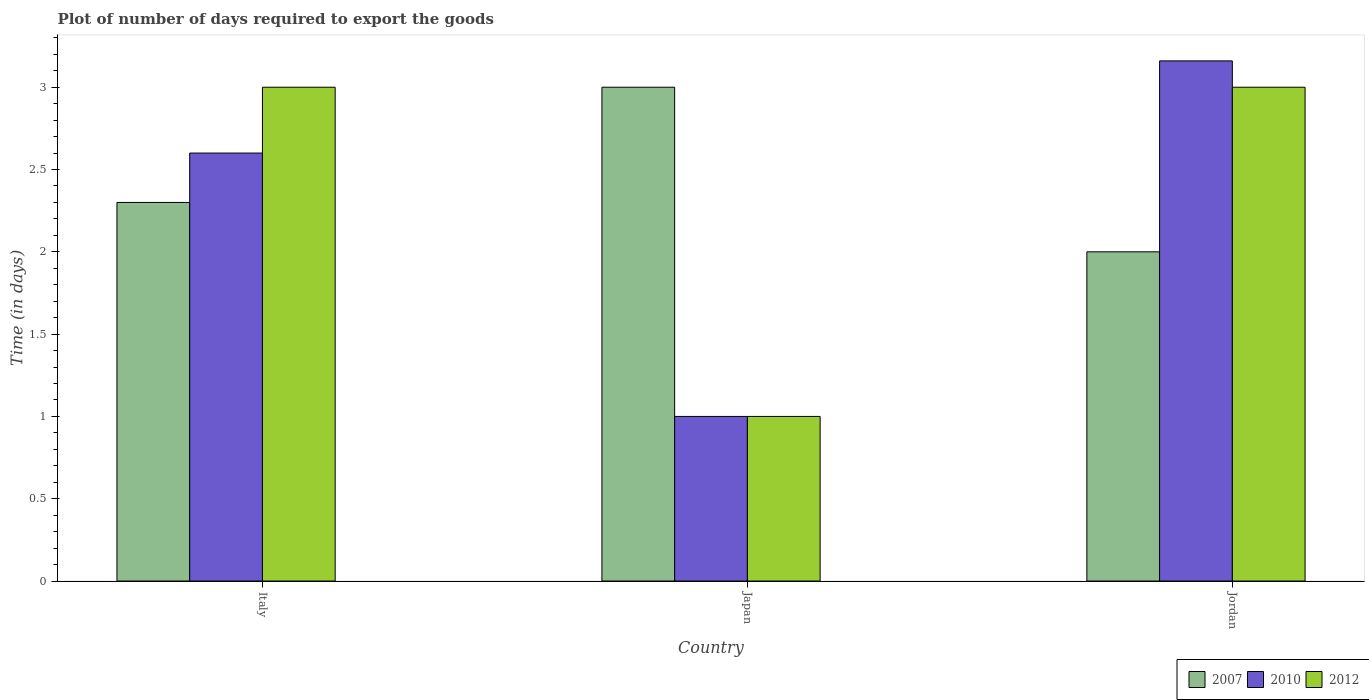How many different coloured bars are there?
Provide a short and direct response. 3. How many groups of bars are there?
Make the answer very short. 3. Are the number of bars per tick equal to the number of legend labels?
Make the answer very short. Yes. How many bars are there on the 3rd tick from the left?
Give a very brief answer. 3. What is the label of the 3rd group of bars from the left?
Keep it short and to the point. Jordan. In how many cases, is the number of bars for a given country not equal to the number of legend labels?
Your answer should be very brief. 0. What is the time required to export goods in 2012 in Italy?
Offer a terse response. 3. Across all countries, what is the maximum time required to export goods in 2010?
Provide a short and direct response. 3.16. In which country was the time required to export goods in 2012 maximum?
Provide a succinct answer. Italy. In which country was the time required to export goods in 2007 minimum?
Your answer should be very brief. Jordan. What is the total time required to export goods in 2010 in the graph?
Your answer should be very brief. 6.76. What is the difference between the time required to export goods in 2007 in Italy and that in Japan?
Make the answer very short. -0.7. What is the difference between the time required to export goods in 2012 in Jordan and the time required to export goods in 2010 in Japan?
Offer a very short reply. 2. What is the average time required to export goods in 2010 per country?
Ensure brevity in your answer.  2.25. What is the difference between the time required to export goods of/in 2012 and time required to export goods of/in 2010 in Jordan?
Your response must be concise. -0.16. What is the ratio of the time required to export goods in 2010 in Japan to that in Jordan?
Make the answer very short. 0.32. Is the difference between the time required to export goods in 2012 in Japan and Jordan greater than the difference between the time required to export goods in 2010 in Japan and Jordan?
Your answer should be very brief. Yes. What is the difference between the highest and the second highest time required to export goods in 2007?
Provide a short and direct response. -0.3. What is the difference between the highest and the lowest time required to export goods in 2012?
Your answer should be very brief. 2. In how many countries, is the time required to export goods in 2007 greater than the average time required to export goods in 2007 taken over all countries?
Your answer should be compact. 1. What does the 1st bar from the left in Japan represents?
Make the answer very short. 2007. What does the 3rd bar from the right in Italy represents?
Give a very brief answer. 2007. Is it the case that in every country, the sum of the time required to export goods in 2012 and time required to export goods in 2007 is greater than the time required to export goods in 2010?
Offer a very short reply. Yes. How many bars are there?
Make the answer very short. 9. Are all the bars in the graph horizontal?
Give a very brief answer. No. How many countries are there in the graph?
Offer a terse response. 3. What is the difference between two consecutive major ticks on the Y-axis?
Your answer should be very brief. 0.5. Where does the legend appear in the graph?
Your answer should be very brief. Bottom right. What is the title of the graph?
Offer a very short reply. Plot of number of days required to export the goods. What is the label or title of the X-axis?
Make the answer very short. Country. What is the label or title of the Y-axis?
Keep it short and to the point. Time (in days). What is the Time (in days) of 2007 in Italy?
Your answer should be very brief. 2.3. What is the Time (in days) in 2010 in Italy?
Your response must be concise. 2.6. What is the Time (in days) of 2012 in Italy?
Make the answer very short. 3. What is the Time (in days) in 2007 in Japan?
Your answer should be compact. 3. What is the Time (in days) in 2012 in Japan?
Provide a short and direct response. 1. What is the Time (in days) in 2007 in Jordan?
Give a very brief answer. 2. What is the Time (in days) in 2010 in Jordan?
Your answer should be very brief. 3.16. Across all countries, what is the maximum Time (in days) in 2010?
Your answer should be very brief. 3.16. What is the total Time (in days) in 2007 in the graph?
Your response must be concise. 7.3. What is the total Time (in days) in 2010 in the graph?
Make the answer very short. 6.76. What is the total Time (in days) of 2012 in the graph?
Make the answer very short. 7. What is the difference between the Time (in days) in 2007 in Italy and that in Japan?
Your response must be concise. -0.7. What is the difference between the Time (in days) of 2012 in Italy and that in Japan?
Provide a short and direct response. 2. What is the difference between the Time (in days) of 2007 in Italy and that in Jordan?
Your answer should be very brief. 0.3. What is the difference between the Time (in days) of 2010 in Italy and that in Jordan?
Provide a short and direct response. -0.56. What is the difference between the Time (in days) of 2010 in Japan and that in Jordan?
Offer a terse response. -2.16. What is the difference between the Time (in days) in 2007 in Italy and the Time (in days) in 2010 in Jordan?
Provide a succinct answer. -0.86. What is the difference between the Time (in days) of 2007 in Japan and the Time (in days) of 2010 in Jordan?
Your answer should be very brief. -0.16. What is the difference between the Time (in days) of 2007 in Japan and the Time (in days) of 2012 in Jordan?
Offer a very short reply. 0. What is the difference between the Time (in days) of 2010 in Japan and the Time (in days) of 2012 in Jordan?
Make the answer very short. -2. What is the average Time (in days) of 2007 per country?
Make the answer very short. 2.43. What is the average Time (in days) in 2010 per country?
Keep it short and to the point. 2.25. What is the average Time (in days) of 2012 per country?
Your response must be concise. 2.33. What is the difference between the Time (in days) of 2007 and Time (in days) of 2010 in Italy?
Make the answer very short. -0.3. What is the difference between the Time (in days) of 2007 and Time (in days) of 2012 in Italy?
Provide a short and direct response. -0.7. What is the difference between the Time (in days) of 2010 and Time (in days) of 2012 in Italy?
Provide a short and direct response. -0.4. What is the difference between the Time (in days) in 2007 and Time (in days) in 2010 in Japan?
Keep it short and to the point. 2. What is the difference between the Time (in days) of 2007 and Time (in days) of 2012 in Japan?
Offer a terse response. 2. What is the difference between the Time (in days) in 2010 and Time (in days) in 2012 in Japan?
Provide a succinct answer. 0. What is the difference between the Time (in days) of 2007 and Time (in days) of 2010 in Jordan?
Keep it short and to the point. -1.16. What is the difference between the Time (in days) of 2007 and Time (in days) of 2012 in Jordan?
Ensure brevity in your answer.  -1. What is the difference between the Time (in days) of 2010 and Time (in days) of 2012 in Jordan?
Provide a succinct answer. 0.16. What is the ratio of the Time (in days) of 2007 in Italy to that in Japan?
Provide a succinct answer. 0.77. What is the ratio of the Time (in days) in 2012 in Italy to that in Japan?
Offer a terse response. 3. What is the ratio of the Time (in days) in 2007 in Italy to that in Jordan?
Make the answer very short. 1.15. What is the ratio of the Time (in days) of 2010 in Italy to that in Jordan?
Your answer should be very brief. 0.82. What is the ratio of the Time (in days) in 2010 in Japan to that in Jordan?
Offer a very short reply. 0.32. What is the ratio of the Time (in days) in 2012 in Japan to that in Jordan?
Make the answer very short. 0.33. What is the difference between the highest and the second highest Time (in days) in 2010?
Ensure brevity in your answer.  0.56. What is the difference between the highest and the second highest Time (in days) in 2012?
Make the answer very short. 0. What is the difference between the highest and the lowest Time (in days) in 2010?
Your response must be concise. 2.16. What is the difference between the highest and the lowest Time (in days) of 2012?
Keep it short and to the point. 2. 